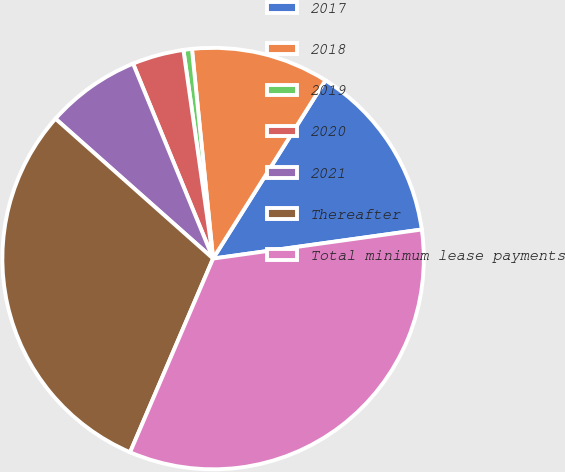Convert chart. <chart><loc_0><loc_0><loc_500><loc_500><pie_chart><fcel>2017<fcel>2018<fcel>2019<fcel>2020<fcel>2021<fcel>Thereafter<fcel>Total minimum lease payments<nl><fcel>13.85%<fcel>10.55%<fcel>0.65%<fcel>3.95%<fcel>7.25%<fcel>30.11%<fcel>33.65%<nl></chart> 